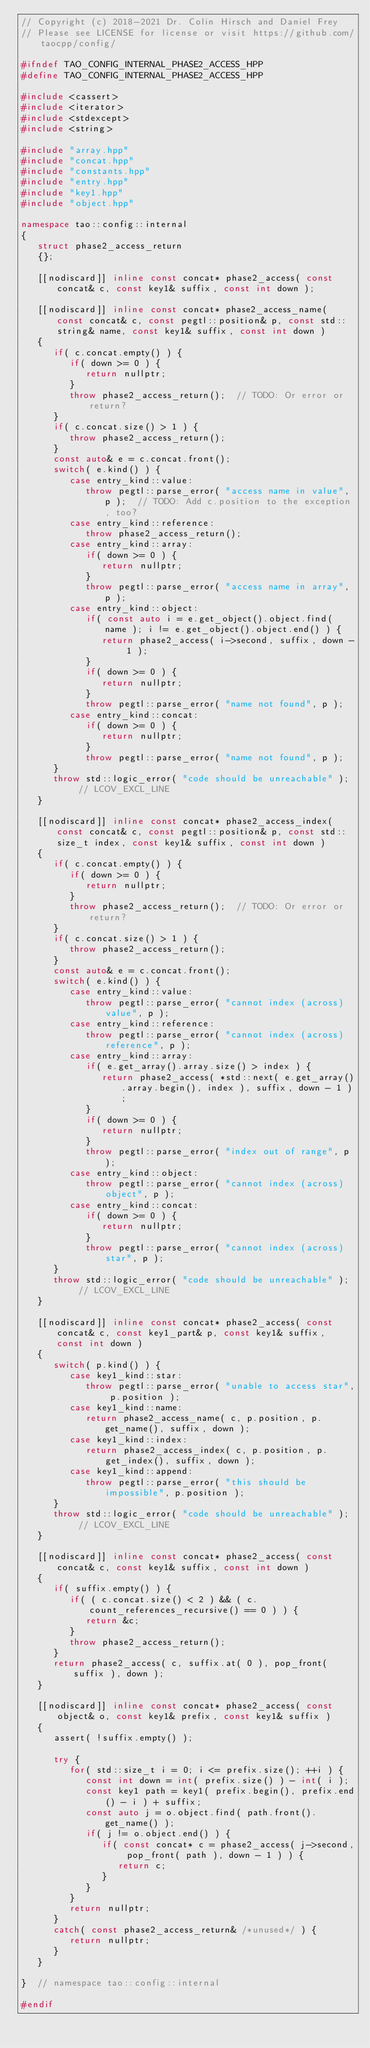Convert code to text. <code><loc_0><loc_0><loc_500><loc_500><_C++_>// Copyright (c) 2018-2021 Dr. Colin Hirsch and Daniel Frey
// Please see LICENSE for license or visit https://github.com/taocpp/config/

#ifndef TAO_CONFIG_INTERNAL_PHASE2_ACCESS_HPP
#define TAO_CONFIG_INTERNAL_PHASE2_ACCESS_HPP

#include <cassert>
#include <iterator>
#include <stdexcept>
#include <string>

#include "array.hpp"
#include "concat.hpp"
#include "constants.hpp"
#include "entry.hpp"
#include "key1.hpp"
#include "object.hpp"

namespace tao::config::internal
{
   struct phase2_access_return
   {};

   [[nodiscard]] inline const concat* phase2_access( const concat& c, const key1& suffix, const int down );

   [[nodiscard]] inline const concat* phase2_access_name( const concat& c, const pegtl::position& p, const std::string& name, const key1& suffix, const int down )
   {
      if( c.concat.empty() ) {
         if( down >= 0 ) {
            return nullptr;
         }
         throw phase2_access_return();  // TODO: Or error or return?
      }
      if( c.concat.size() > 1 ) {
         throw phase2_access_return();
      }
      const auto& e = c.concat.front();
      switch( e.kind() ) {
         case entry_kind::value:
            throw pegtl::parse_error( "access name in value", p );  // TODO: Add c.position to the exception, too?
         case entry_kind::reference:
            throw phase2_access_return();
         case entry_kind::array:
            if( down >= 0 ) {
               return nullptr;
            }
            throw pegtl::parse_error( "access name in array", p );
         case entry_kind::object:
            if( const auto i = e.get_object().object.find( name ); i != e.get_object().object.end() ) {
               return phase2_access( i->second, suffix, down - 1 );
            }
            if( down >= 0 ) {
               return nullptr;
            }
            throw pegtl::parse_error( "name not found", p );
         case entry_kind::concat:
            if( down >= 0 ) {
               return nullptr;
            }
            throw pegtl::parse_error( "name not found", p );
      }
      throw std::logic_error( "code should be unreachable" );  // LCOV_EXCL_LINE
   }

   [[nodiscard]] inline const concat* phase2_access_index( const concat& c, const pegtl::position& p, const std::size_t index, const key1& suffix, const int down )
   {
      if( c.concat.empty() ) {
         if( down >= 0 ) {
            return nullptr;
         }
         throw phase2_access_return();  // TODO: Or error or return?
      }
      if( c.concat.size() > 1 ) {
         throw phase2_access_return();
      }
      const auto& e = c.concat.front();
      switch( e.kind() ) {
         case entry_kind::value:
            throw pegtl::parse_error( "cannot index (across) value", p );
         case entry_kind::reference:
            throw pegtl::parse_error( "cannot index (across) reference", p );
         case entry_kind::array:
            if( e.get_array().array.size() > index ) {
               return phase2_access( *std::next( e.get_array().array.begin(), index ), suffix, down - 1 );
            }
            if( down >= 0 ) {
               return nullptr;
            }
            throw pegtl::parse_error( "index out of range", p );
         case entry_kind::object:
            throw pegtl::parse_error( "cannot index (across) object", p );
         case entry_kind::concat:
            if( down >= 0 ) {
               return nullptr;
            }
            throw pegtl::parse_error( "cannot index (across) star", p );
      }
      throw std::logic_error( "code should be unreachable" );  // LCOV_EXCL_LINE
   }

   [[nodiscard]] inline const concat* phase2_access( const concat& c, const key1_part& p, const key1& suffix, const int down )
   {
      switch( p.kind() ) {
         case key1_kind::star:
            throw pegtl::parse_error( "unable to access star", p.position );
         case key1_kind::name:
            return phase2_access_name( c, p.position, p.get_name(), suffix, down );
         case key1_kind::index:
            return phase2_access_index( c, p.position, p.get_index(), suffix, down );
         case key1_kind::append:
            throw pegtl::parse_error( "this should be impossible", p.position );
      }
      throw std::logic_error( "code should be unreachable" );  // LCOV_EXCL_LINE
   }

   [[nodiscard]] inline const concat* phase2_access( const concat& c, const key1& suffix, const int down )
   {
      if( suffix.empty() ) {
         if( ( c.concat.size() < 2 ) && ( c.count_references_recursive() == 0 ) ) {
            return &c;
         }
         throw phase2_access_return();
      }
      return phase2_access( c, suffix.at( 0 ), pop_front( suffix ), down );
   }

   [[nodiscard]] inline const concat* phase2_access( const object& o, const key1& prefix, const key1& suffix )
   {
      assert( !suffix.empty() );

      try {
         for( std::size_t i = 0; i <= prefix.size(); ++i ) {
            const int down = int( prefix.size() ) - int( i );
            const key1 path = key1( prefix.begin(), prefix.end() - i ) + suffix;
            const auto j = o.object.find( path.front().get_name() );
            if( j != o.object.end() ) {
               if( const concat* c = phase2_access( j->second, pop_front( path ), down - 1 ) ) {
                  return c;
               }
            }
         }
         return nullptr;
      }
      catch( const phase2_access_return& /*unused*/ ) {
         return nullptr;
      }
   }

}  // namespace tao::config::internal

#endif
</code> 